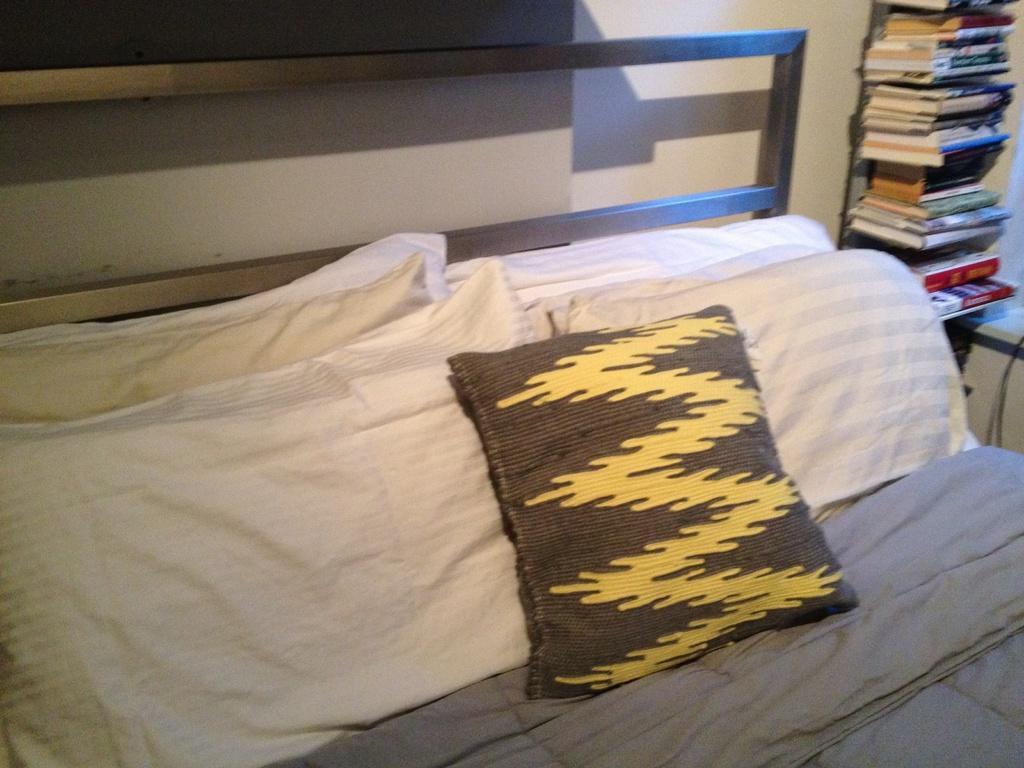Could you give a brief overview of what you see in this image? In this image we can see the bed with pillows and blanket and to the side, there is a bookshelf with books. We can see the wall. 